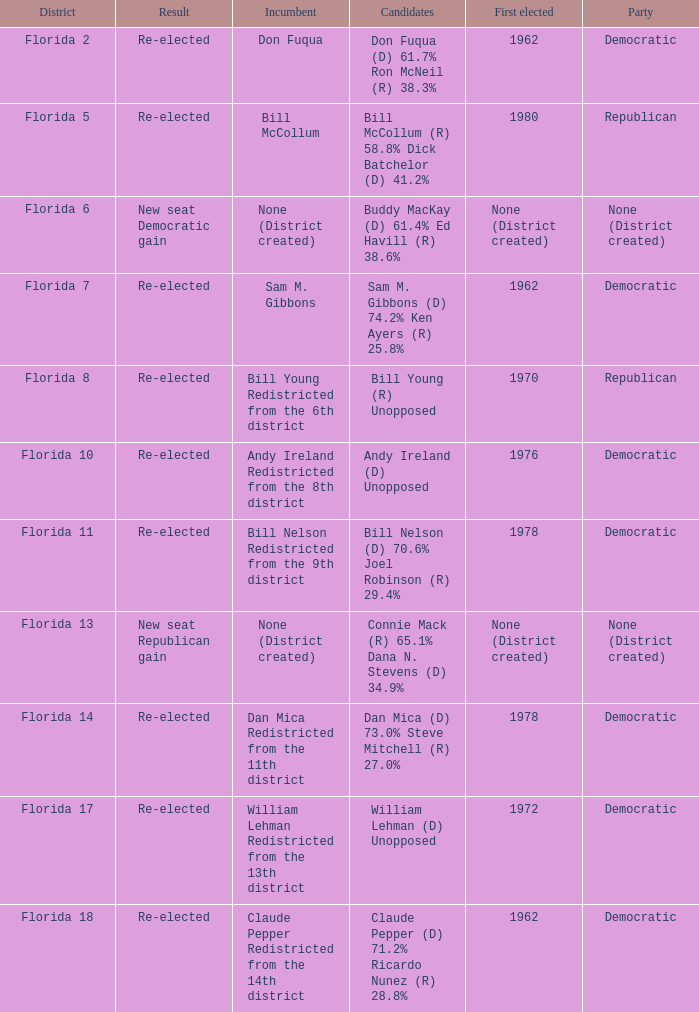Who is the the candidates with incumbent being don fuqua Don Fuqua (D) 61.7% Ron McNeil (R) 38.3%. 